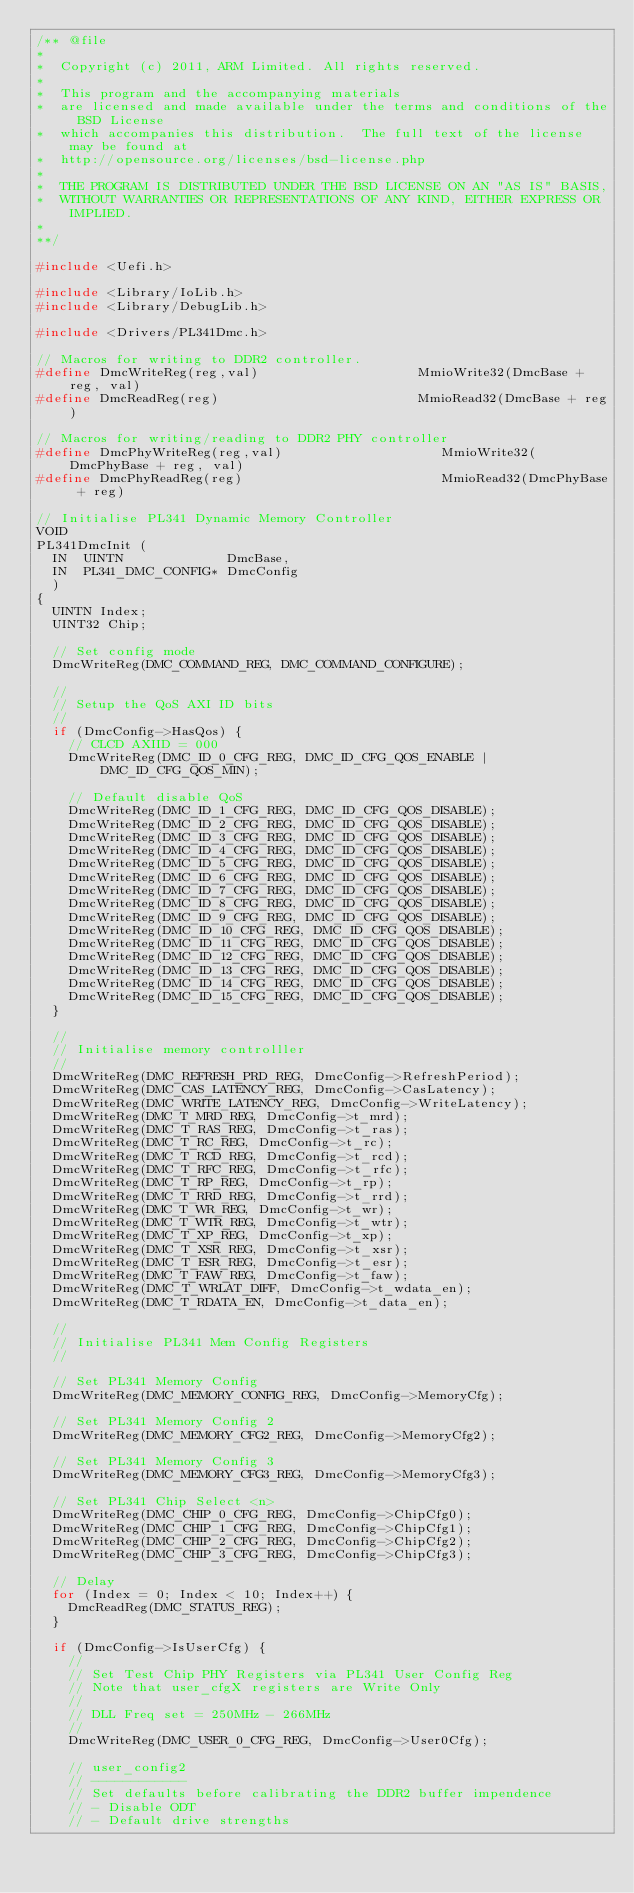Convert code to text. <code><loc_0><loc_0><loc_500><loc_500><_C_>/** @file
*
*  Copyright (c) 2011, ARM Limited. All rights reserved.
*
*  This program and the accompanying materials
*  are licensed and made available under the terms and conditions of the BSD License
*  which accompanies this distribution.  The full text of the license may be found at
*  http://opensource.org/licenses/bsd-license.php
*
*  THE PROGRAM IS DISTRIBUTED UNDER THE BSD LICENSE ON AN "AS IS" BASIS,
*  WITHOUT WARRANTIES OR REPRESENTATIONS OF ANY KIND, EITHER EXPRESS OR IMPLIED.
*
**/

#include <Uefi.h>

#include <Library/IoLib.h>
#include <Library/DebugLib.h>

#include <Drivers/PL341Dmc.h>

// Macros for writing to DDR2 controller.
#define DmcWriteReg(reg,val)                    MmioWrite32(DmcBase + reg, val)
#define DmcReadReg(reg)                         MmioRead32(DmcBase + reg)

// Macros for writing/reading to DDR2 PHY controller
#define DmcPhyWriteReg(reg,val)                    MmioWrite32(DmcPhyBase + reg, val)
#define DmcPhyReadReg(reg)                         MmioRead32(DmcPhyBase + reg)

// Initialise PL341 Dynamic Memory Controller
VOID
PL341DmcInit (
  IN  UINTN             DmcBase,
  IN  PL341_DMC_CONFIG* DmcConfig
  )
{
  UINTN Index;
  UINT32 Chip;

  // Set config mode
  DmcWriteReg(DMC_COMMAND_REG, DMC_COMMAND_CONFIGURE);

  //
  // Setup the QoS AXI ID bits
  //
  if (DmcConfig->HasQos) {
    // CLCD AXIID = 000
    DmcWriteReg(DMC_ID_0_CFG_REG, DMC_ID_CFG_QOS_ENABLE | DMC_ID_CFG_QOS_MIN);

    // Default disable QoS
    DmcWriteReg(DMC_ID_1_CFG_REG, DMC_ID_CFG_QOS_DISABLE);
    DmcWriteReg(DMC_ID_2_CFG_REG, DMC_ID_CFG_QOS_DISABLE);
    DmcWriteReg(DMC_ID_3_CFG_REG, DMC_ID_CFG_QOS_DISABLE);
    DmcWriteReg(DMC_ID_4_CFG_REG, DMC_ID_CFG_QOS_DISABLE);
    DmcWriteReg(DMC_ID_5_CFG_REG, DMC_ID_CFG_QOS_DISABLE);
    DmcWriteReg(DMC_ID_6_CFG_REG, DMC_ID_CFG_QOS_DISABLE);
    DmcWriteReg(DMC_ID_7_CFG_REG, DMC_ID_CFG_QOS_DISABLE);
    DmcWriteReg(DMC_ID_8_CFG_REG, DMC_ID_CFG_QOS_DISABLE);
    DmcWriteReg(DMC_ID_9_CFG_REG, DMC_ID_CFG_QOS_DISABLE);
    DmcWriteReg(DMC_ID_10_CFG_REG, DMC_ID_CFG_QOS_DISABLE);
    DmcWriteReg(DMC_ID_11_CFG_REG, DMC_ID_CFG_QOS_DISABLE);
    DmcWriteReg(DMC_ID_12_CFG_REG, DMC_ID_CFG_QOS_DISABLE);
    DmcWriteReg(DMC_ID_13_CFG_REG, DMC_ID_CFG_QOS_DISABLE);
    DmcWriteReg(DMC_ID_14_CFG_REG, DMC_ID_CFG_QOS_DISABLE);
    DmcWriteReg(DMC_ID_15_CFG_REG, DMC_ID_CFG_QOS_DISABLE);
  }

  //
  // Initialise memory controlller
  //
  DmcWriteReg(DMC_REFRESH_PRD_REG, DmcConfig->RefreshPeriod);
  DmcWriteReg(DMC_CAS_LATENCY_REG, DmcConfig->CasLatency);
  DmcWriteReg(DMC_WRITE_LATENCY_REG, DmcConfig->WriteLatency);
  DmcWriteReg(DMC_T_MRD_REG, DmcConfig->t_mrd);
  DmcWriteReg(DMC_T_RAS_REG, DmcConfig->t_ras);
  DmcWriteReg(DMC_T_RC_REG, DmcConfig->t_rc);
  DmcWriteReg(DMC_T_RCD_REG, DmcConfig->t_rcd);
  DmcWriteReg(DMC_T_RFC_REG, DmcConfig->t_rfc);
  DmcWriteReg(DMC_T_RP_REG, DmcConfig->t_rp);
  DmcWriteReg(DMC_T_RRD_REG, DmcConfig->t_rrd);
  DmcWriteReg(DMC_T_WR_REG, DmcConfig->t_wr);
  DmcWriteReg(DMC_T_WTR_REG, DmcConfig->t_wtr);
  DmcWriteReg(DMC_T_XP_REG, DmcConfig->t_xp);
  DmcWriteReg(DMC_T_XSR_REG, DmcConfig->t_xsr);
  DmcWriteReg(DMC_T_ESR_REG, DmcConfig->t_esr);
  DmcWriteReg(DMC_T_FAW_REG, DmcConfig->t_faw);
  DmcWriteReg(DMC_T_WRLAT_DIFF, DmcConfig->t_wdata_en);
  DmcWriteReg(DMC_T_RDATA_EN, DmcConfig->t_data_en);

  //
  // Initialise PL341 Mem Config Registers
  //

  // Set PL341 Memory Config
  DmcWriteReg(DMC_MEMORY_CONFIG_REG, DmcConfig->MemoryCfg);

  // Set PL341 Memory Config 2
  DmcWriteReg(DMC_MEMORY_CFG2_REG, DmcConfig->MemoryCfg2);

  // Set PL341 Memory Config 3
  DmcWriteReg(DMC_MEMORY_CFG3_REG, DmcConfig->MemoryCfg3);

  // Set PL341 Chip Select <n>
  DmcWriteReg(DMC_CHIP_0_CFG_REG, DmcConfig->ChipCfg0);
  DmcWriteReg(DMC_CHIP_1_CFG_REG, DmcConfig->ChipCfg1);
  DmcWriteReg(DMC_CHIP_2_CFG_REG, DmcConfig->ChipCfg2);
  DmcWriteReg(DMC_CHIP_3_CFG_REG, DmcConfig->ChipCfg3);

  // Delay
  for (Index = 0; Index < 10; Index++) {
    DmcReadReg(DMC_STATUS_REG);
  }

  if (DmcConfig->IsUserCfg) {
    //
    // Set Test Chip PHY Registers via PL341 User Config Reg
    // Note that user_cfgX registers are Write Only
    //
    // DLL Freq set = 250MHz - 266MHz
    //
    DmcWriteReg(DMC_USER_0_CFG_REG, DmcConfig->User0Cfg);

    // user_config2
    // ------------
    // Set defaults before calibrating the DDR2 buffer impendence
    // - Disable ODT
    // - Default drive strengths</code> 